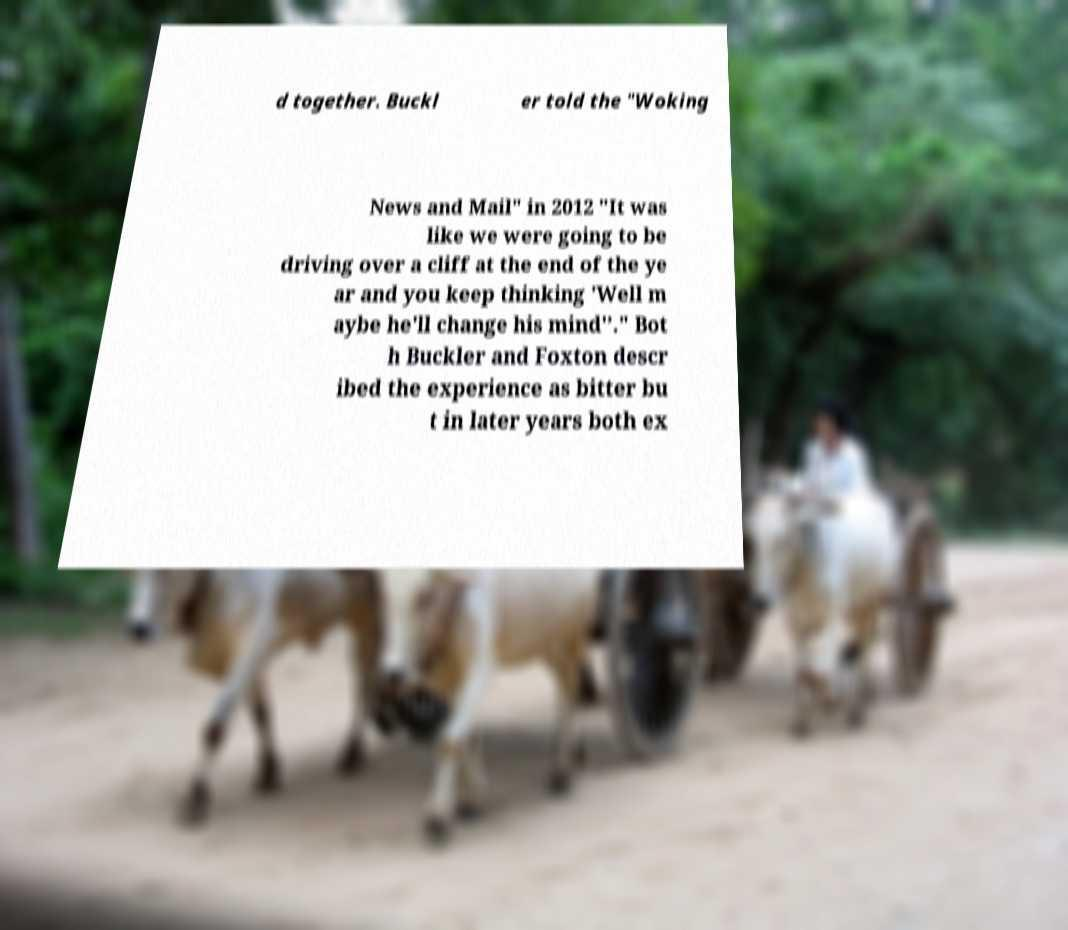Can you read and provide the text displayed in the image?This photo seems to have some interesting text. Can you extract and type it out for me? d together. Buckl er told the "Woking News and Mail" in 2012 "It was like we were going to be driving over a cliff at the end of the ye ar and you keep thinking 'Well m aybe he'll change his mind'’." Bot h Buckler and Foxton descr ibed the experience as bitter bu t in later years both ex 